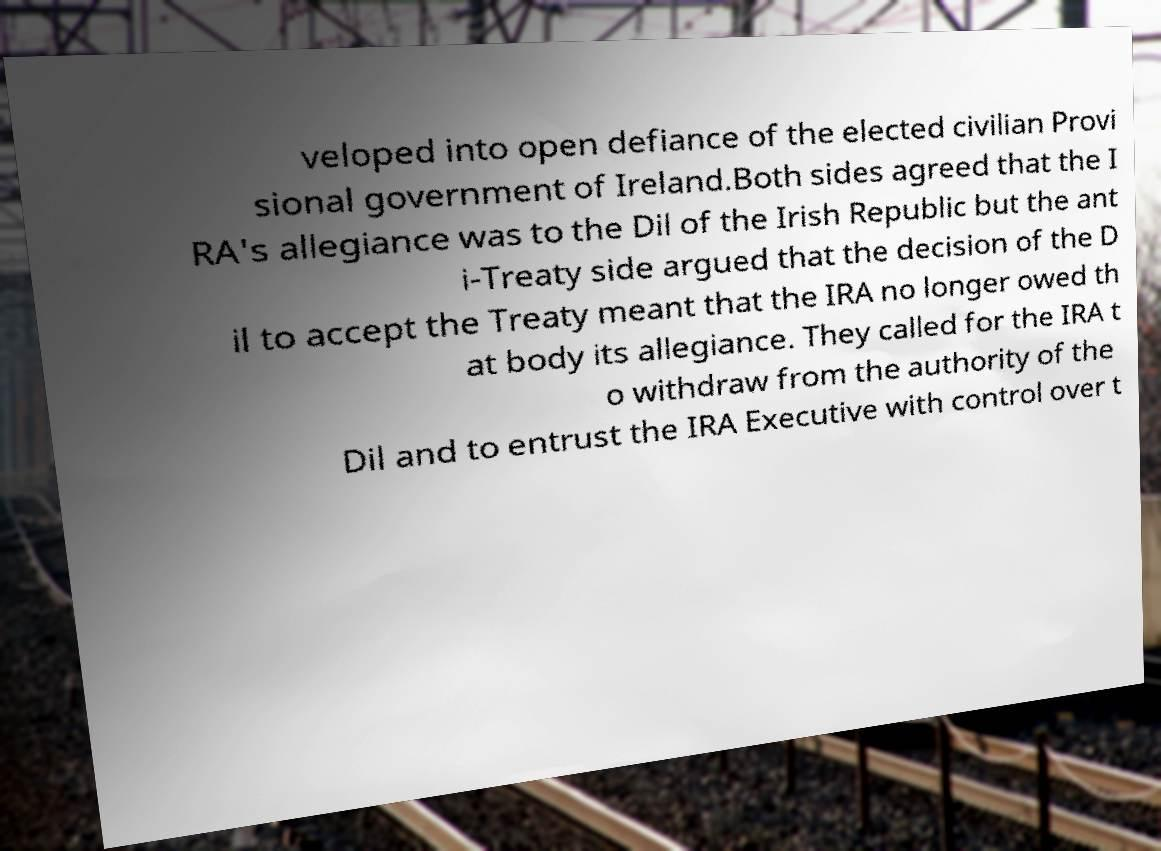Can you read and provide the text displayed in the image?This photo seems to have some interesting text. Can you extract and type it out for me? veloped into open defiance of the elected civilian Provi sional government of Ireland.Both sides agreed that the I RA's allegiance was to the Dil of the Irish Republic but the ant i-Treaty side argued that the decision of the D il to accept the Treaty meant that the IRA no longer owed th at body its allegiance. They called for the IRA t o withdraw from the authority of the Dil and to entrust the IRA Executive with control over t 